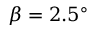Convert formula to latex. <formula><loc_0><loc_0><loc_500><loc_500>\beta = 2 . 5 ^ { \circ }</formula> 